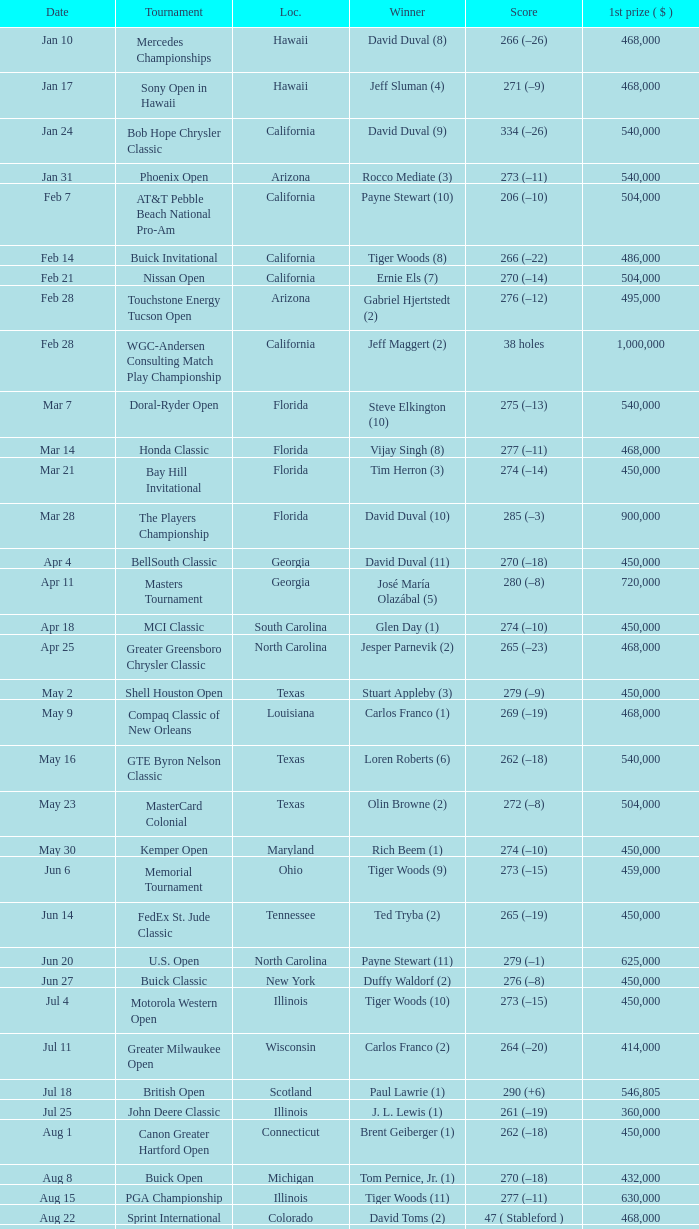What is the score of the B.C. Open in New York? 273 (–15). 